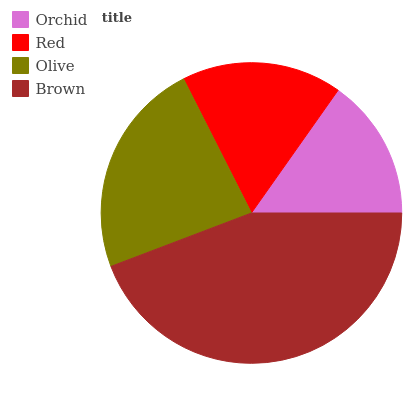Is Orchid the minimum?
Answer yes or no. Yes. Is Brown the maximum?
Answer yes or no. Yes. Is Red the minimum?
Answer yes or no. No. Is Red the maximum?
Answer yes or no. No. Is Red greater than Orchid?
Answer yes or no. Yes. Is Orchid less than Red?
Answer yes or no. Yes. Is Orchid greater than Red?
Answer yes or no. No. Is Red less than Orchid?
Answer yes or no. No. Is Olive the high median?
Answer yes or no. Yes. Is Red the low median?
Answer yes or no. Yes. Is Brown the high median?
Answer yes or no. No. Is Orchid the low median?
Answer yes or no. No. 